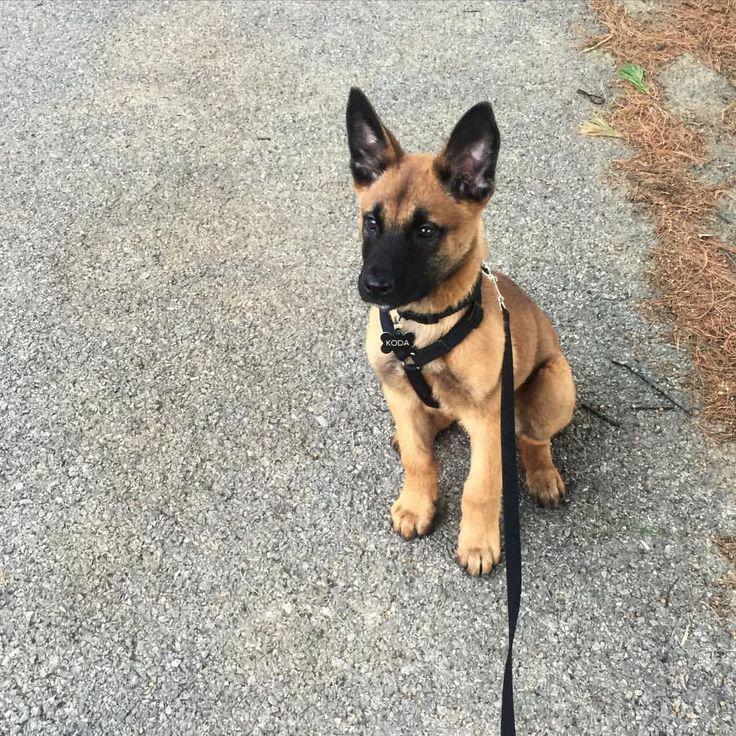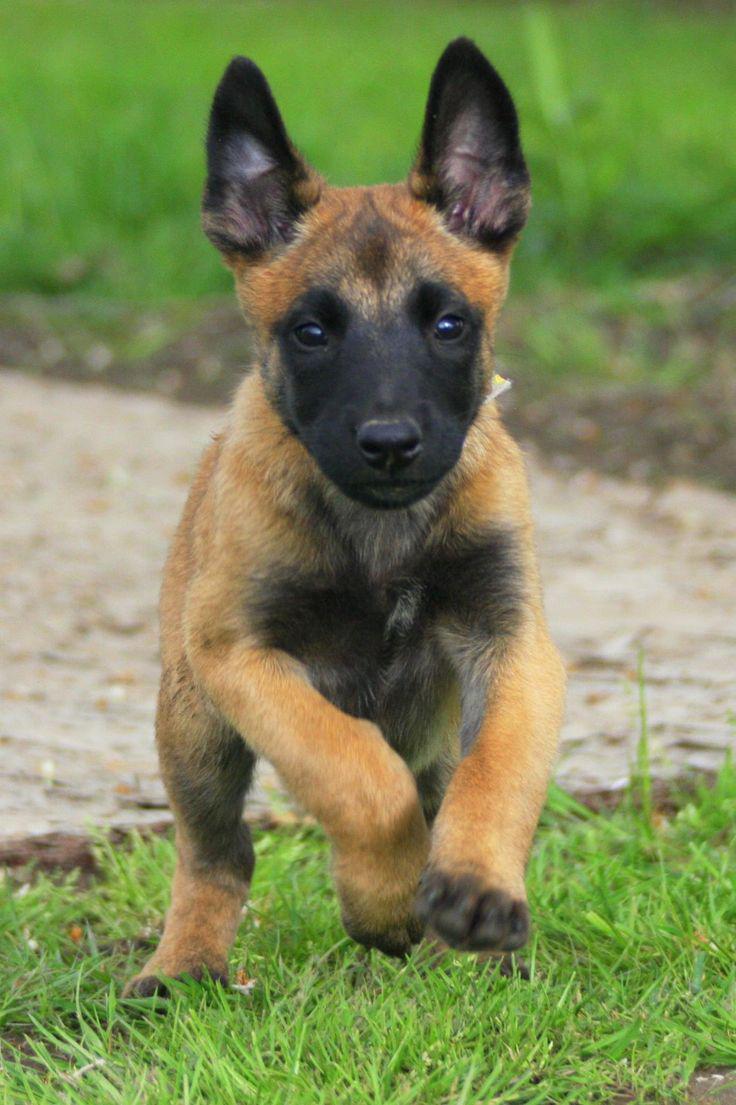The first image is the image on the left, the second image is the image on the right. Analyze the images presented: Is the assertion "All the dogs pictured are resting on the grassy ground." valid? Answer yes or no. No. 